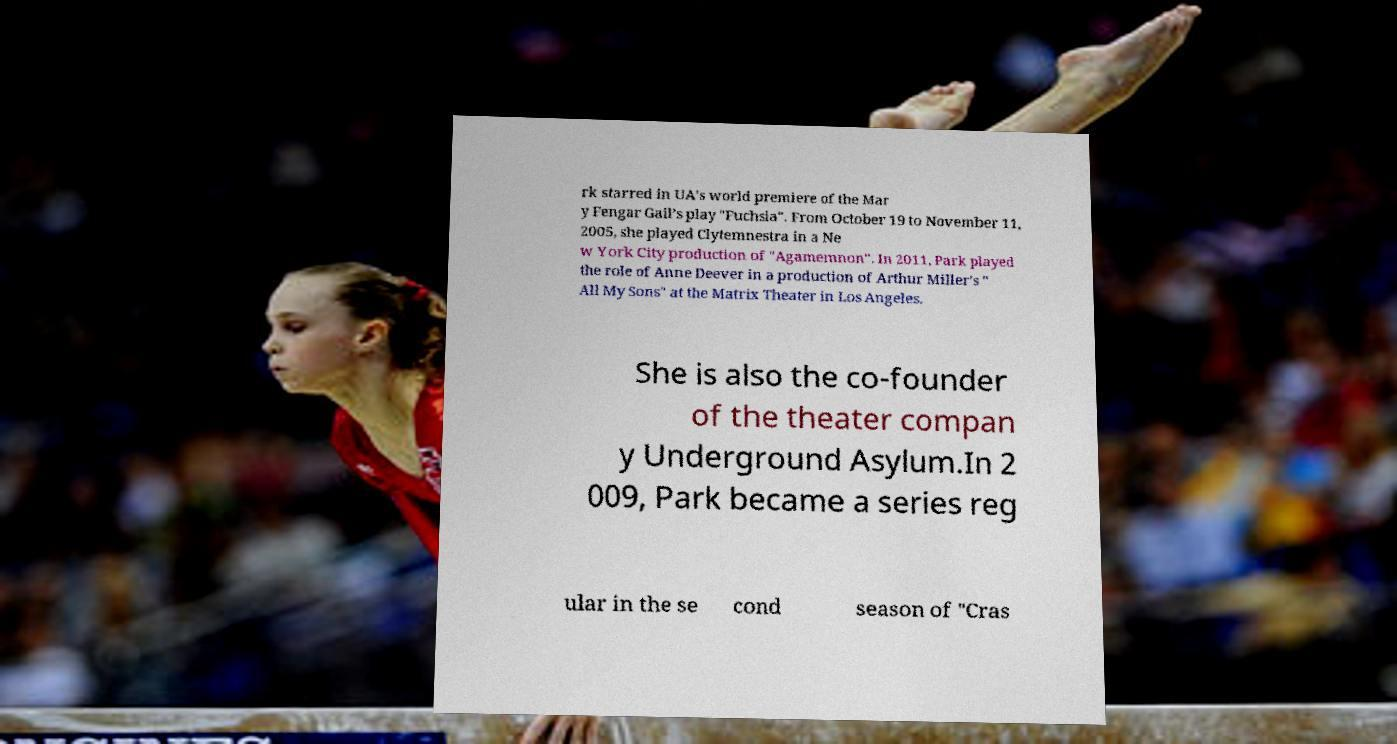For documentation purposes, I need the text within this image transcribed. Could you provide that? rk starred in UA's world premiere of the Mar y Fengar Gail’s play "Fuchsia". From October 19 to November 11, 2005, she played Clytemnestra in a Ne w York City production of "Agamemnon". In 2011, Park played the role of Anne Deever in a production of Arthur Miller's " All My Sons" at the Matrix Theater in Los Angeles. She is also the co-founder of the theater compan y Underground Asylum.In 2 009, Park became a series reg ular in the se cond season of "Cras 